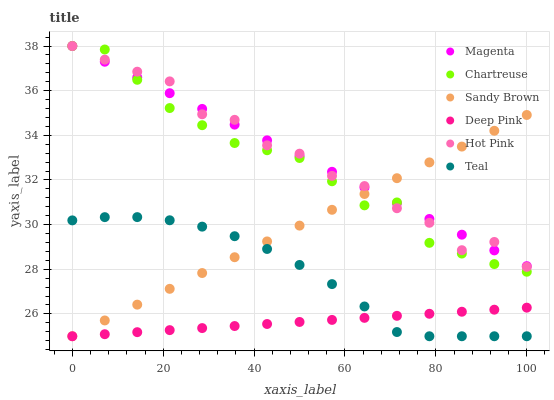Does Deep Pink have the minimum area under the curve?
Answer yes or no. Yes. Does Magenta have the maximum area under the curve?
Answer yes or no. Yes. Does Hot Pink have the minimum area under the curve?
Answer yes or no. No. Does Hot Pink have the maximum area under the curve?
Answer yes or no. No. Is Sandy Brown the smoothest?
Answer yes or no. Yes. Is Hot Pink the roughest?
Answer yes or no. Yes. Is Chartreuse the smoothest?
Answer yes or no. No. Is Chartreuse the roughest?
Answer yes or no. No. Does Deep Pink have the lowest value?
Answer yes or no. Yes. Does Hot Pink have the lowest value?
Answer yes or no. No. Does Magenta have the highest value?
Answer yes or no. Yes. Does Teal have the highest value?
Answer yes or no. No. Is Deep Pink less than Hot Pink?
Answer yes or no. Yes. Is Chartreuse greater than Teal?
Answer yes or no. Yes. Does Hot Pink intersect Chartreuse?
Answer yes or no. Yes. Is Hot Pink less than Chartreuse?
Answer yes or no. No. Is Hot Pink greater than Chartreuse?
Answer yes or no. No. Does Deep Pink intersect Hot Pink?
Answer yes or no. No. 